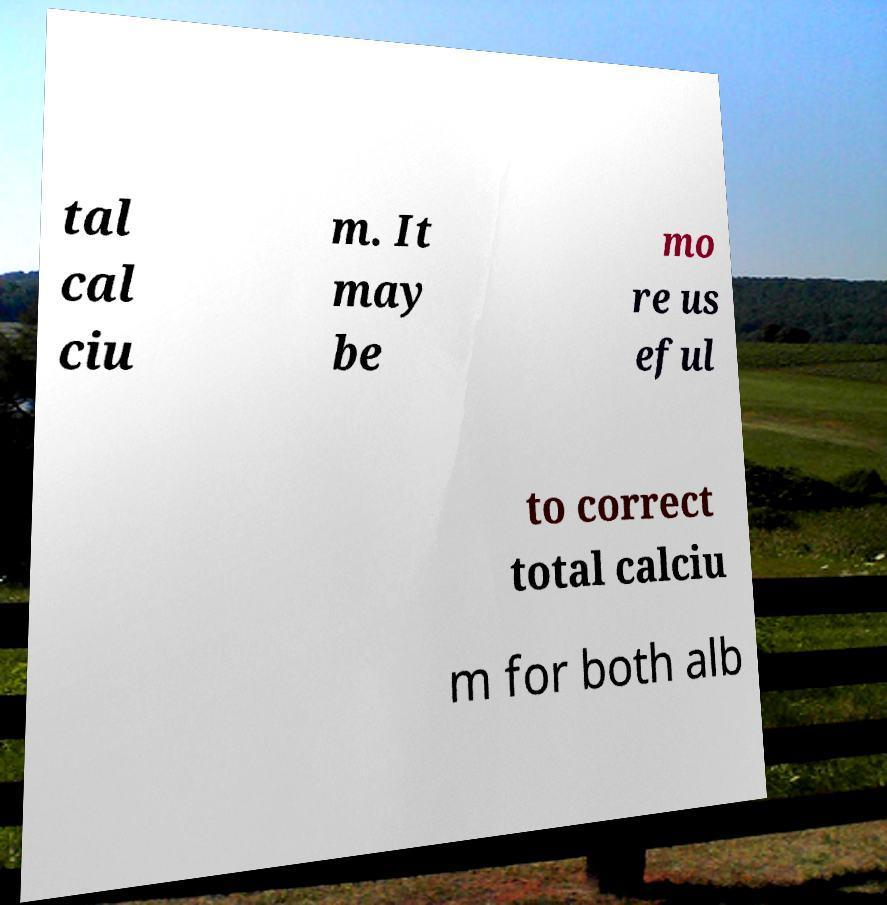I need the written content from this picture converted into text. Can you do that? tal cal ciu m. It may be mo re us eful to correct total calciu m for both alb 